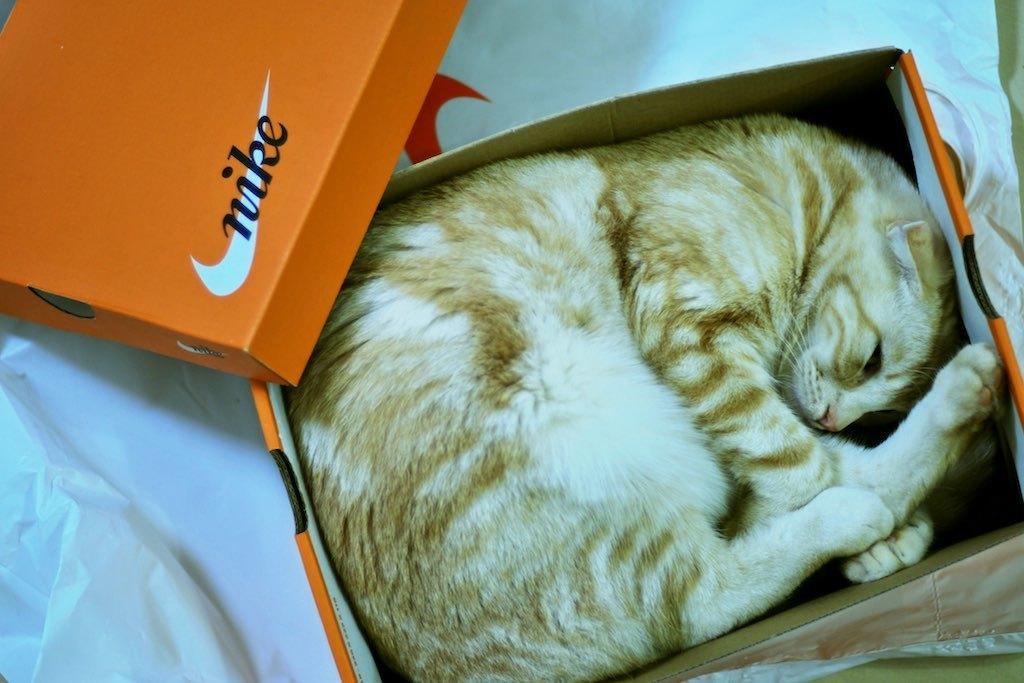Describe this image in one or two sentences. In this image we can see a cat sleeping in the cardboard box. At the bottom there is a cover. 